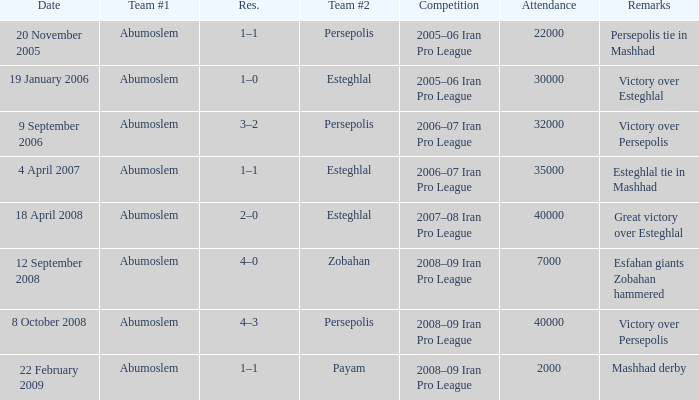What are the remarks for 8 October 2008? Victory over Persepolis. 